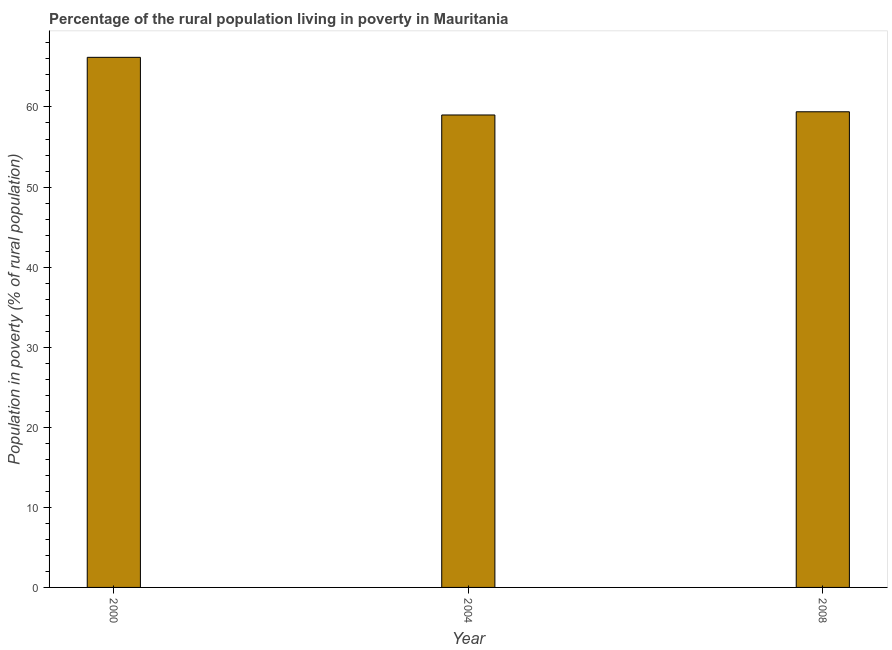Does the graph contain any zero values?
Provide a short and direct response. No. What is the title of the graph?
Your answer should be compact. Percentage of the rural population living in poverty in Mauritania. What is the label or title of the Y-axis?
Provide a succinct answer. Population in poverty (% of rural population). What is the percentage of rural population living below poverty line in 2000?
Offer a very short reply. 66.2. Across all years, what is the maximum percentage of rural population living below poverty line?
Offer a very short reply. 66.2. Across all years, what is the minimum percentage of rural population living below poverty line?
Give a very brief answer. 59. In which year was the percentage of rural population living below poverty line maximum?
Provide a succinct answer. 2000. In which year was the percentage of rural population living below poverty line minimum?
Provide a short and direct response. 2004. What is the sum of the percentage of rural population living below poverty line?
Offer a terse response. 184.6. What is the average percentage of rural population living below poverty line per year?
Keep it short and to the point. 61.53. What is the median percentage of rural population living below poverty line?
Keep it short and to the point. 59.4. Do a majority of the years between 2008 and 2000 (inclusive) have percentage of rural population living below poverty line greater than 42 %?
Give a very brief answer. Yes. What is the ratio of the percentage of rural population living below poverty line in 2000 to that in 2004?
Provide a succinct answer. 1.12. What is the difference between the highest and the second highest percentage of rural population living below poverty line?
Offer a very short reply. 6.8. In how many years, is the percentage of rural population living below poverty line greater than the average percentage of rural population living below poverty line taken over all years?
Provide a short and direct response. 1. Are all the bars in the graph horizontal?
Provide a short and direct response. No. How many years are there in the graph?
Keep it short and to the point. 3. What is the Population in poverty (% of rural population) in 2000?
Keep it short and to the point. 66.2. What is the Population in poverty (% of rural population) of 2004?
Offer a very short reply. 59. What is the Population in poverty (% of rural population) of 2008?
Ensure brevity in your answer.  59.4. What is the difference between the Population in poverty (% of rural population) in 2000 and 2004?
Give a very brief answer. 7.2. What is the ratio of the Population in poverty (% of rural population) in 2000 to that in 2004?
Your answer should be compact. 1.12. What is the ratio of the Population in poverty (% of rural population) in 2000 to that in 2008?
Your answer should be compact. 1.11. What is the ratio of the Population in poverty (% of rural population) in 2004 to that in 2008?
Offer a terse response. 0.99. 